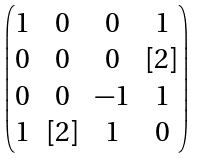<formula> <loc_0><loc_0><loc_500><loc_500>\begin{pmatrix} 1 & 0 & 0 & 1 \\ 0 & 0 & 0 & [ 2 ] \\ 0 & 0 & - 1 & 1 \\ 1 & [ 2 ] & 1 & 0 \end{pmatrix}</formula> 